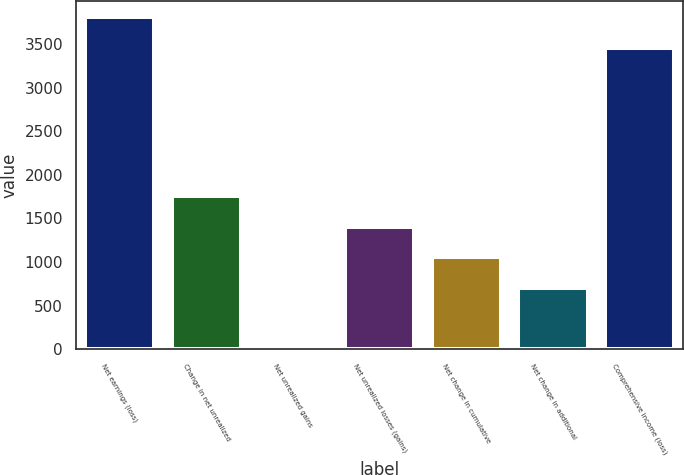<chart> <loc_0><loc_0><loc_500><loc_500><bar_chart><fcel>Net earnings (loss)<fcel>Change in net unrealized<fcel>Net unrealized gains<fcel>Net unrealized losses (gains)<fcel>Net change in cumulative<fcel>Net change in additional<fcel>Comprehensive income (loss)<nl><fcel>3805.9<fcel>1752.5<fcel>8<fcel>1403.6<fcel>1054.7<fcel>705.8<fcel>3457<nl></chart> 